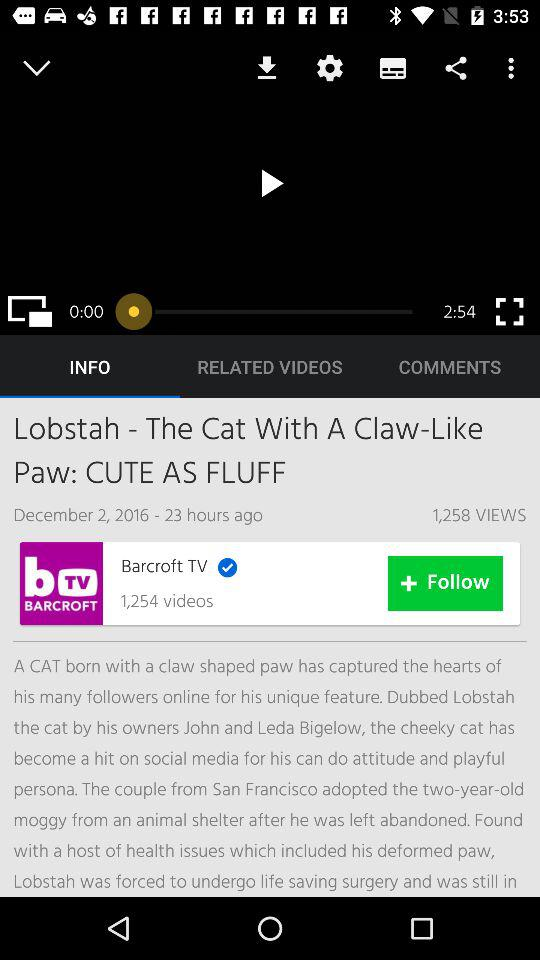How many views are there of the video shown on the screen? There are 1,258 views of the video shown on the screen. 